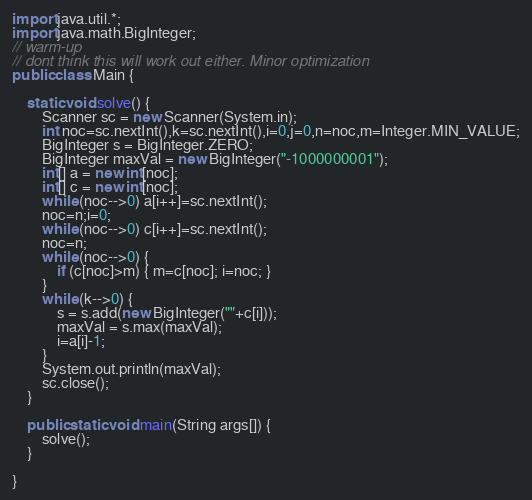Convert code to text. <code><loc_0><loc_0><loc_500><loc_500><_Java_>import java.util.*;
import java.math.BigInteger;
// warm-up
// dont think this will work out either. Minor optimization
public class Main {

	static void solve() {
		Scanner sc = new Scanner(System.in);
		int noc=sc.nextInt(),k=sc.nextInt(),i=0,j=0,n=noc,m=Integer.MIN_VALUE;
		BigInteger s = BigInteger.ZERO;
		BigInteger maxVal = new BigInteger("-1000000001");
		int[] a = new int[noc];
		int[] c = new int[noc];
		while (noc-->0) a[i++]=sc.nextInt();
		noc=n;i=0;
		while (noc-->0) c[i++]=sc.nextInt();
		noc=n;
		while (noc-->0) {
			if (c[noc]>m) { m=c[noc]; i=noc; } 
		}
		while (k-->0) {
			s = s.add(new BigInteger(""+c[i]));
			maxVal = s.max(maxVal);
			i=a[i]-1;
		}
		System.out.println(maxVal);
		sc.close();	
	}

	public static void main(String args[]) {
		solve();
	}

}
</code> 